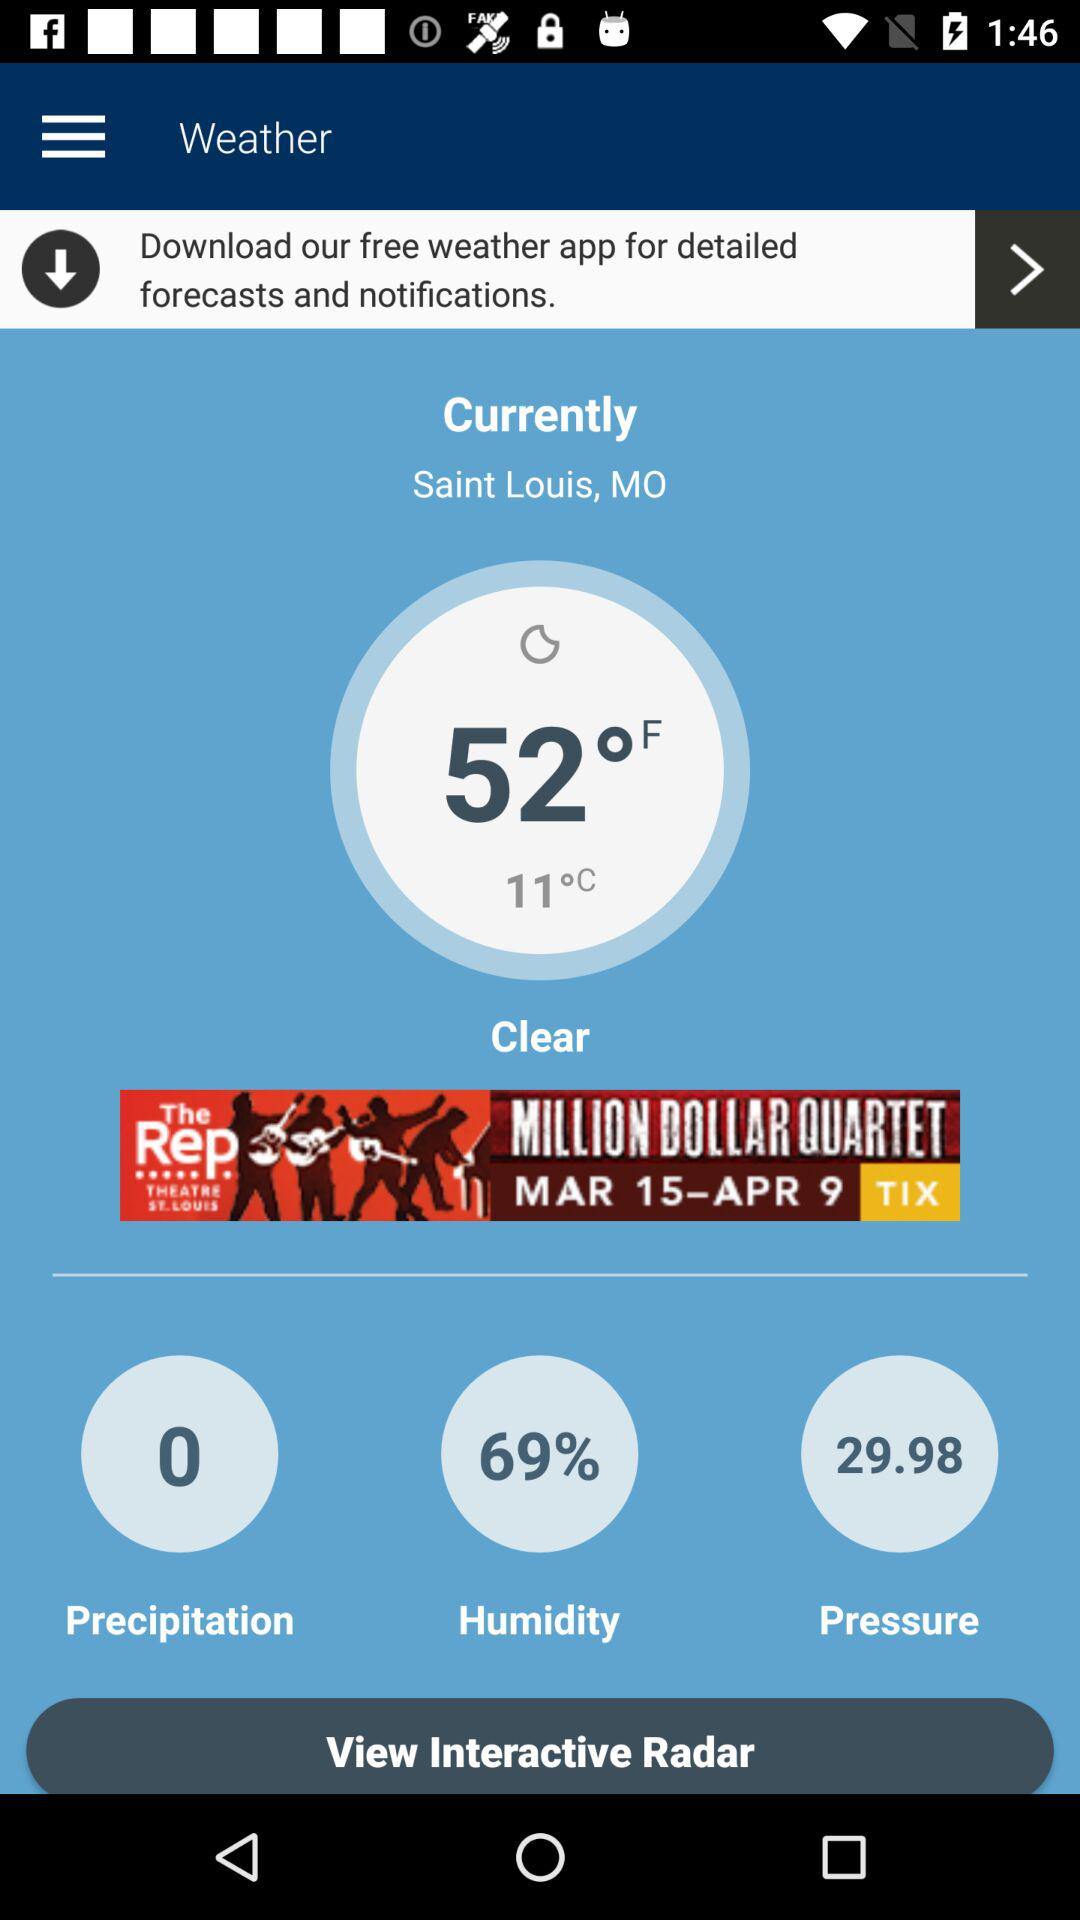What is the temperature in Fahrenheit?
Answer the question using a single word or phrase. 52°F 